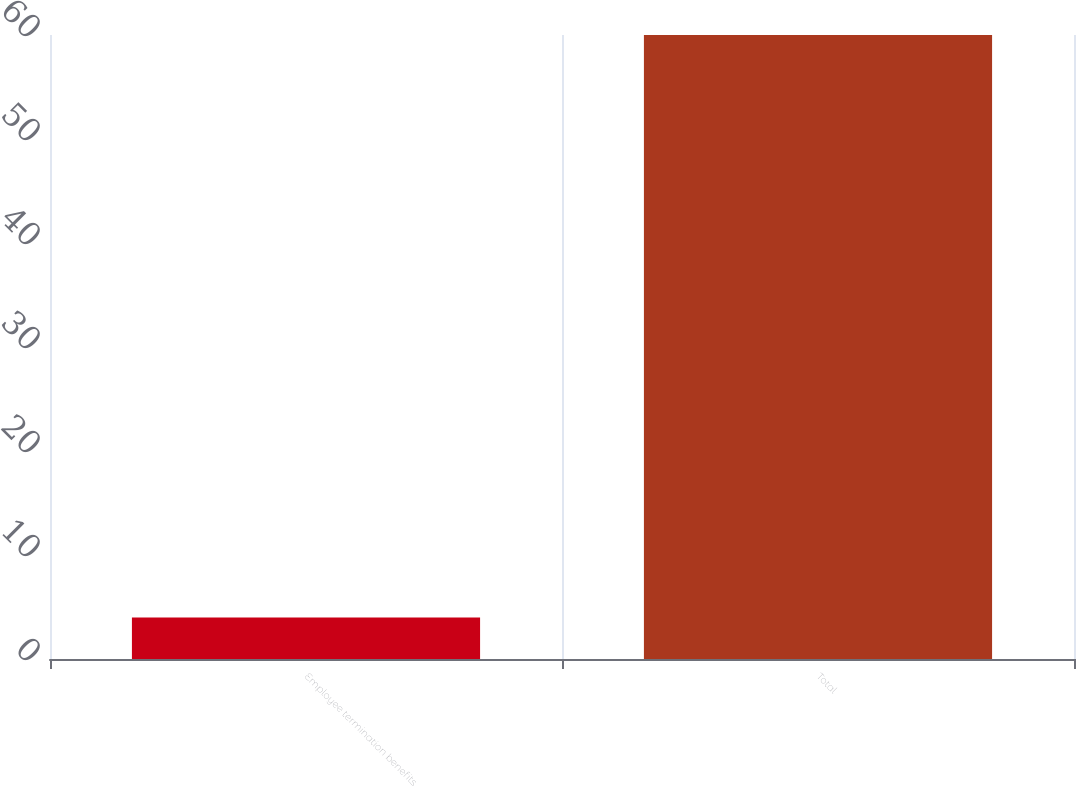<chart> <loc_0><loc_0><loc_500><loc_500><bar_chart><fcel>Employee termination benefits<fcel>Total<nl><fcel>4<fcel>60<nl></chart> 